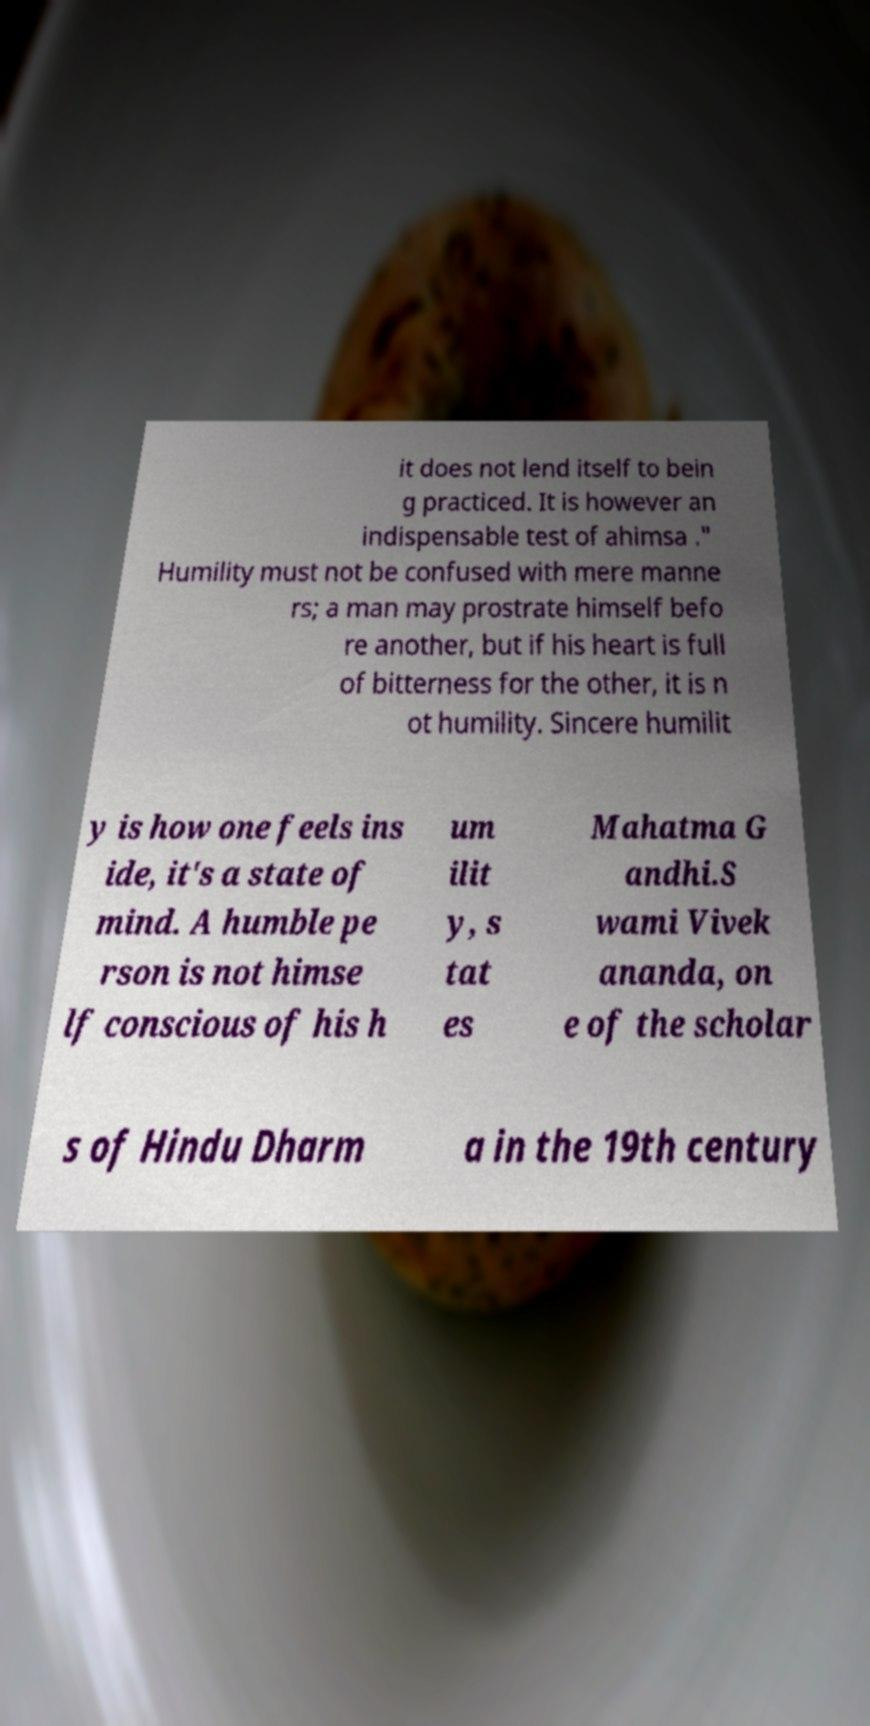Please read and relay the text visible in this image. What does it say? it does not lend itself to bein g practiced. It is however an indispensable test of ahimsa ." Humility must not be confused with mere manne rs; a man may prostrate himself befo re another, but if his heart is full of bitterness for the other, it is n ot humility. Sincere humilit y is how one feels ins ide, it's a state of mind. A humble pe rson is not himse lf conscious of his h um ilit y, s tat es Mahatma G andhi.S wami Vivek ananda, on e of the scholar s of Hindu Dharm a in the 19th century 